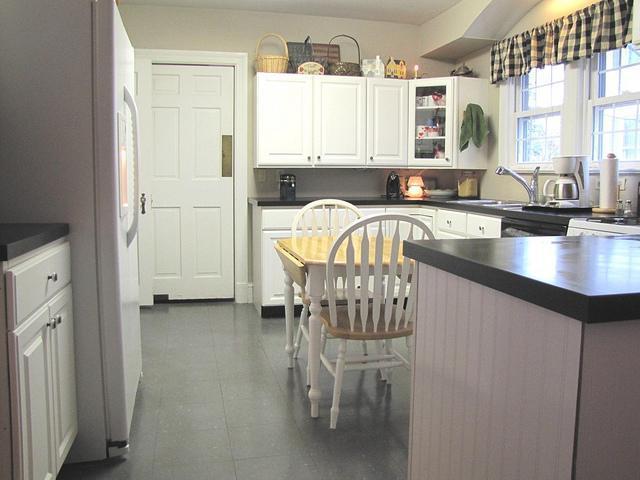How many chairs are in the photo?
Give a very brief answer. 1. How many skateboards are shown?
Give a very brief answer. 0. 